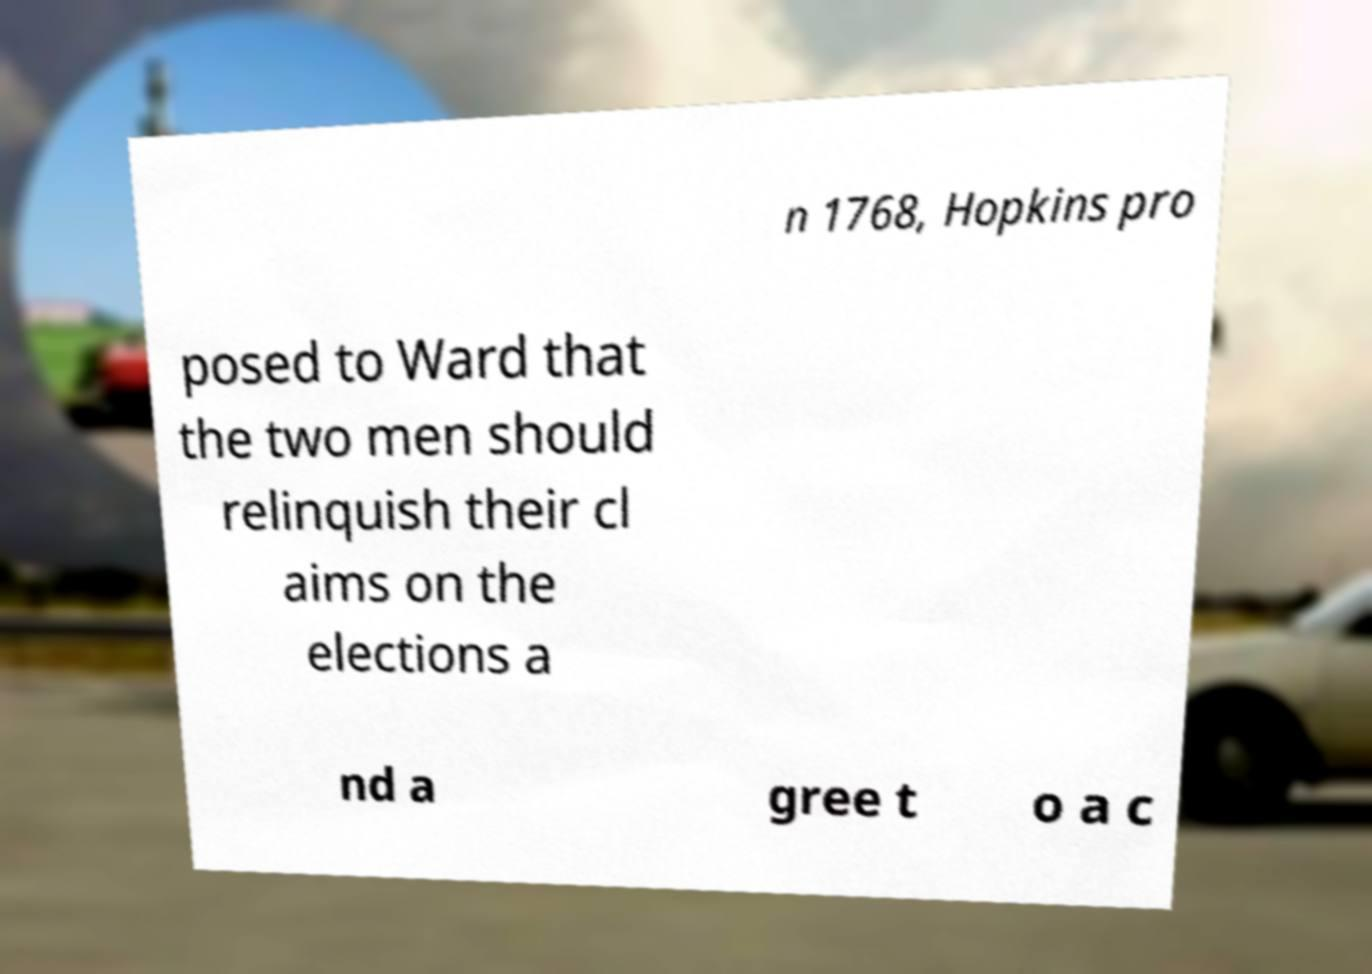Can you read and provide the text displayed in the image?This photo seems to have some interesting text. Can you extract and type it out for me? n 1768, Hopkins pro posed to Ward that the two men should relinquish their cl aims on the elections a nd a gree t o a c 